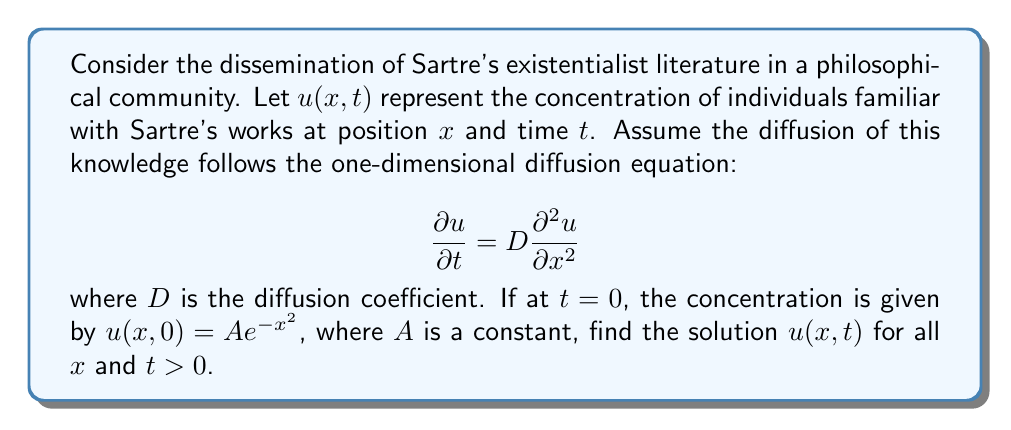Give your solution to this math problem. To solve this problem, we'll use the method of separation of variables and Fourier transforms.

1) The general solution to the diffusion equation is of the form:

   $$u(x,t) = \frac{1}{\sqrt{4\pi Dt}} \int_{-\infty}^{\infty} u(y,0) e^{-\frac{(x-y)^2}{4Dt}} dy$$

2) Substituting the initial condition $u(x,0) = Ae^{-x^2}$:

   $$u(x,t) = \frac{A}{\sqrt{4\pi Dt}} \int_{-\infty}^{\infty} e^{-y^2} e^{-\frac{(x-y)^2}{4Dt}} dy$$

3) To evaluate this integral, we can complete the square in the exponent:

   $$-y^2 - \frac{(x-y)^2}{4Dt} = -\left(1+\frac{1}{4Dt}\right)y^2 + \frac{xy}{2Dt} - \frac{x^2}{4Dt}$$
   
   $$= -\left(1+\frac{1}{4Dt}\right)\left(y^2 - \frac{xy}{2Dt(1+\frac{1}{4Dt})} + \frac{x^2}{4Dt(1+\frac{1}{4Dt})^2}\right) - \frac{x^2}{4Dt} + \frac{x^2}{4Dt(1+\frac{1}{4Dt})}$$

4) Let $\alpha = 1+\frac{1}{4Dt}$. Then the integral becomes:

   $$u(x,t) = \frac{A}{\sqrt{4\pi Dt}} e^{-\frac{x^2}{4Dt(1+4Dt)}} \int_{-\infty}^{\infty} e^{-\alpha(y-\frac{x}{2Dt\alpha})^2} dy$$

5) This integral is a standard Gaussian integral, which evaluates to:

   $$\int_{-\infty}^{\infty} e^{-\alpha(y-\frac{x}{2Dt\alpha})^2} dy = \sqrt{\frac{\pi}{\alpha}}$$

6) Substituting back and simplifying:

   $$u(x,t) = \frac{A}{\sqrt{1+4Dt}} e^{-\frac{x^2}{4Dt(1+4Dt)}}$$

This is the solution for the concentration of individuals familiar with Sartre's works at position $x$ and time $t$.
Answer: $$u(x,t) = \frac{A}{\sqrt{1+4Dt}} e^{-\frac{x^2}{4Dt(1+4Dt)}}$$ 